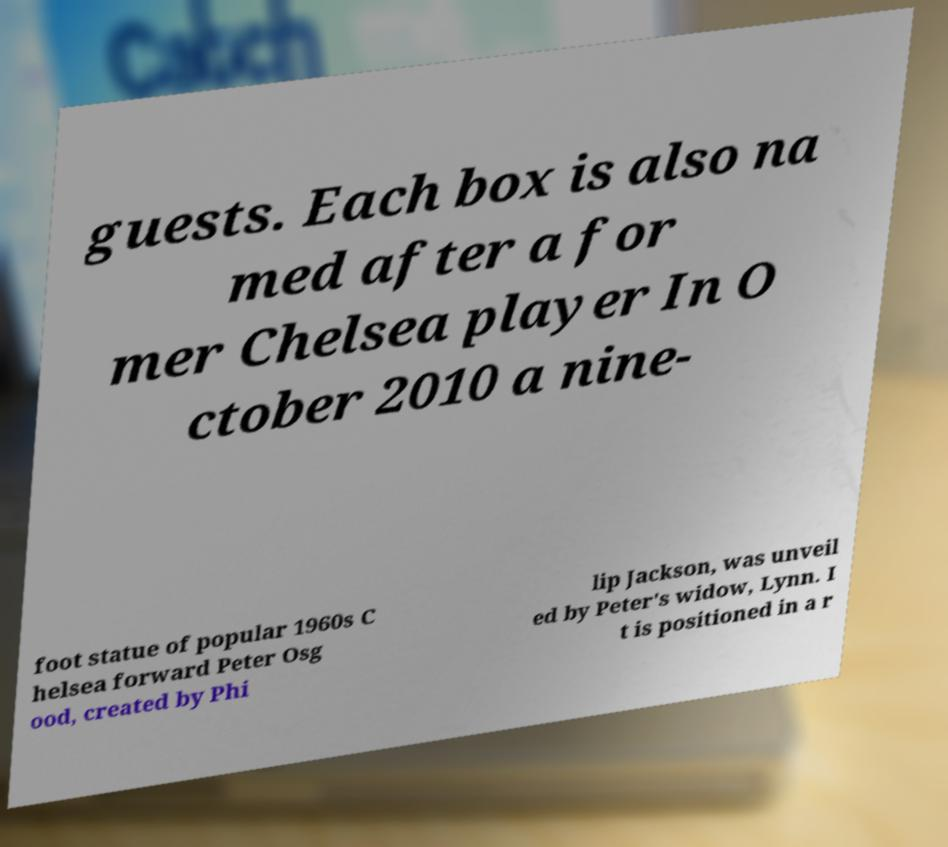Please read and relay the text visible in this image. What does it say? guests. Each box is also na med after a for mer Chelsea player In O ctober 2010 a nine- foot statue of popular 1960s C helsea forward Peter Osg ood, created by Phi lip Jackson, was unveil ed by Peter's widow, Lynn. I t is positioned in a r 